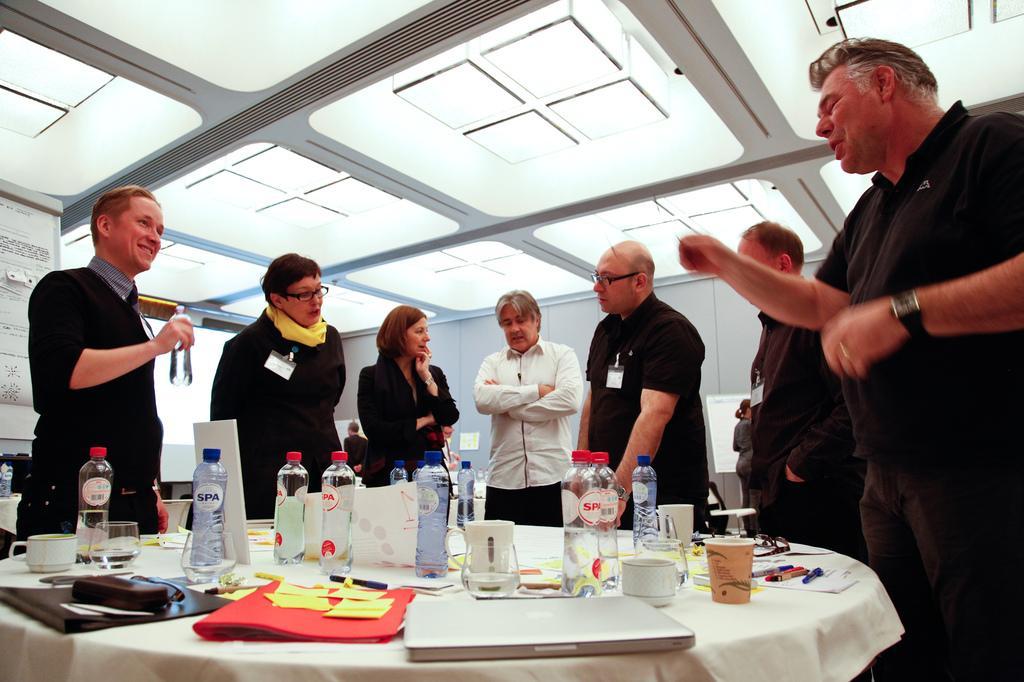Can you describe this image briefly? In this image few people are standing. On the table there is a laptop,cup,water bottles,file paper,pen. 